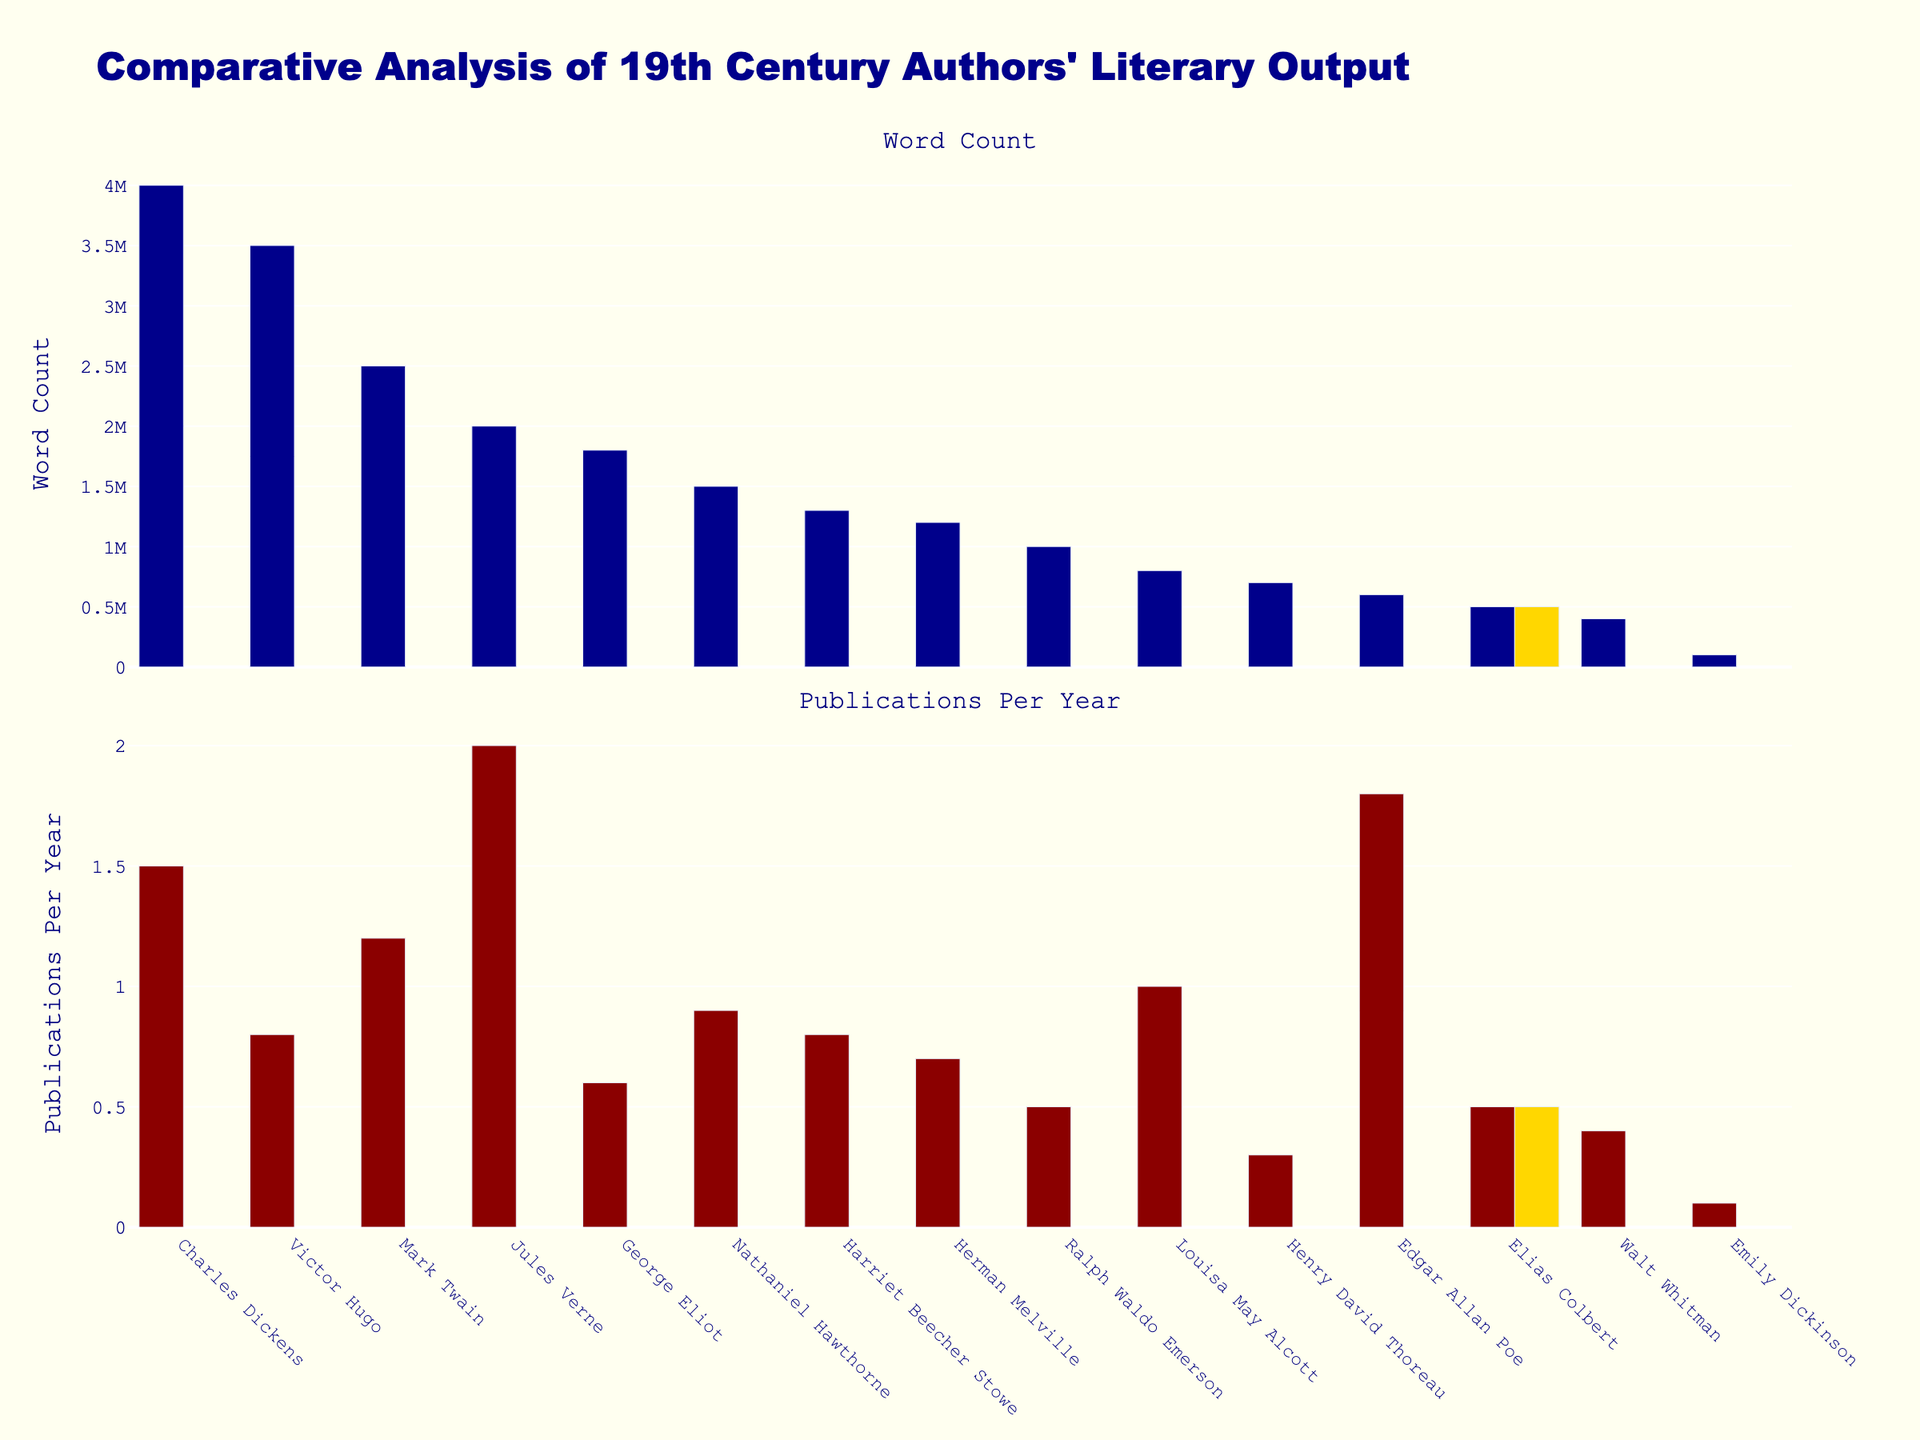How many authors are represented in this figure? The figure displays a bar for each author. By counting the distinct bars, we can determine the number of authors displayed.
Answer: 15 What is the title of the plot? The title of the plot is prominently displayed at the top of the figure.
Answer: Comparative Analysis of 19th Century Authors' Literary Output What color is used to highlight Elias Colbert's bar in both subplots? The legend and the bar color indicate the specific selection for Elias Colbert.
Answer: Gold Who has the highest word count among these 19th-century authors? Reviewing the "Word Count" bar plot, the tallest bar reflects the author with the highest word count.
Answer: Charles Dickens Who has the lowest publication frequency per year? In the "Publications Per Year" subplot, the shortest bar shows the author with the lowest publication frequency.
Answer: Emily Dickinson What is the average word count for these 19th-century authors? To find the average word count, sum all the word counts and divide by the number of authors: (4000000 + 2500000 + 2000000 + 3500000 + 800000 + 500000 + 100000 + 1200000 + 1500000 + 600000 + 1800000 + 400000 + 700000 + 1000000 + 1300000) / 15 = 21733333 / 15 = 1448888.87
Answer: 1448889 How many authors have a publication frequency of more than 1.0 per year? Count the number of bars in the "Publications Per Year" plot that exceed the value of 1.0 on the y-axis.
Answer: 5 Which authors have a word count less than 1,000,000? Identify the authors in the "Word Count" subplot with bars representing values lower than 1,000,000.
Answer: Louisa May Alcott, Elias Colbert, Emily Dickinson, Edgar Allan Poe, Walt Whitman, Henry David Thoreau How does Elias Colbert's word count compare to that of Edgar Allan Poe? Compare the heights of the specific bars representing Elias Colbert and Edgar Allan Poe in the "Word Count" subplot.
Answer: Elias Colbert's word count is lower than Edgar Allan Poe's Which author has the highest publication frequency but a word count less than 2,000,000? Identify the author in the "Publications Per Year" plot with the highest frequency and then check their word count in the "Word Count" subplot.
Answer: Jules Verne 